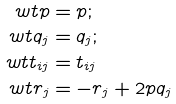Convert formula to latex. <formula><loc_0><loc_0><loc_500><loc_500>\ w t p & = p ; \\ \ w t q _ { j } & = q _ { j } ; \\ \ w t t _ { i j } & = t _ { i j } \\ \ w t r _ { j } & = - r _ { j } + 2 p q _ { j }</formula> 